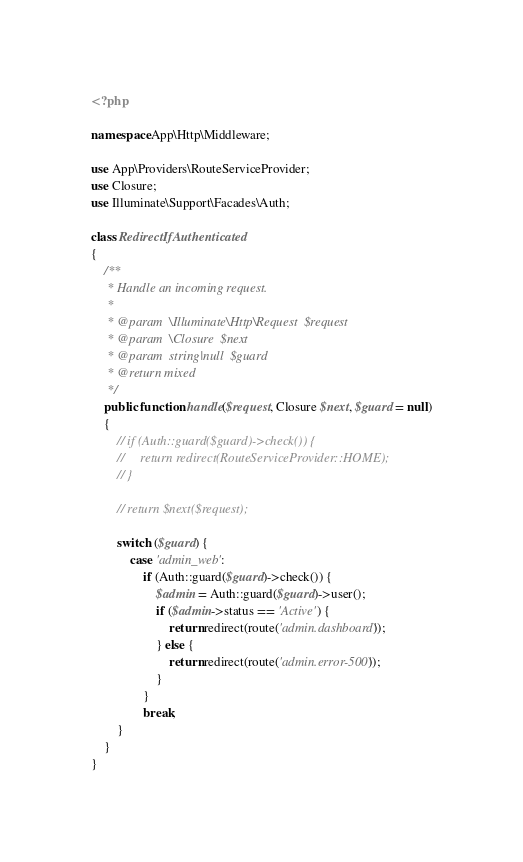<code> <loc_0><loc_0><loc_500><loc_500><_PHP_><?php

namespace App\Http\Middleware;

use App\Providers\RouteServiceProvider;
use Closure;
use Illuminate\Support\Facades\Auth;

class RedirectIfAuthenticated
{
    /**
     * Handle an incoming request.
     *
     * @param  \Illuminate\Http\Request  $request
     * @param  \Closure  $next
     * @param  string|null  $guard
     * @return mixed
     */
    public function handle($request, Closure $next, $guard = null)
    {
        // if (Auth::guard($guard)->check()) {
        //     return redirect(RouteServiceProvider::HOME);
        // }

        // return $next($request);

        switch ($guard) {
            case 'admin_web':
                if (Auth::guard($guard)->check()) {
                    $admin = Auth::guard($guard)->user();
                    if ($admin->status == 'Active') {
                        return redirect(route('admin.dashboard'));
                    } else {
                        return redirect(route('admin.error-500'));
                    }
                }
                break;
        }
    }
}
</code> 